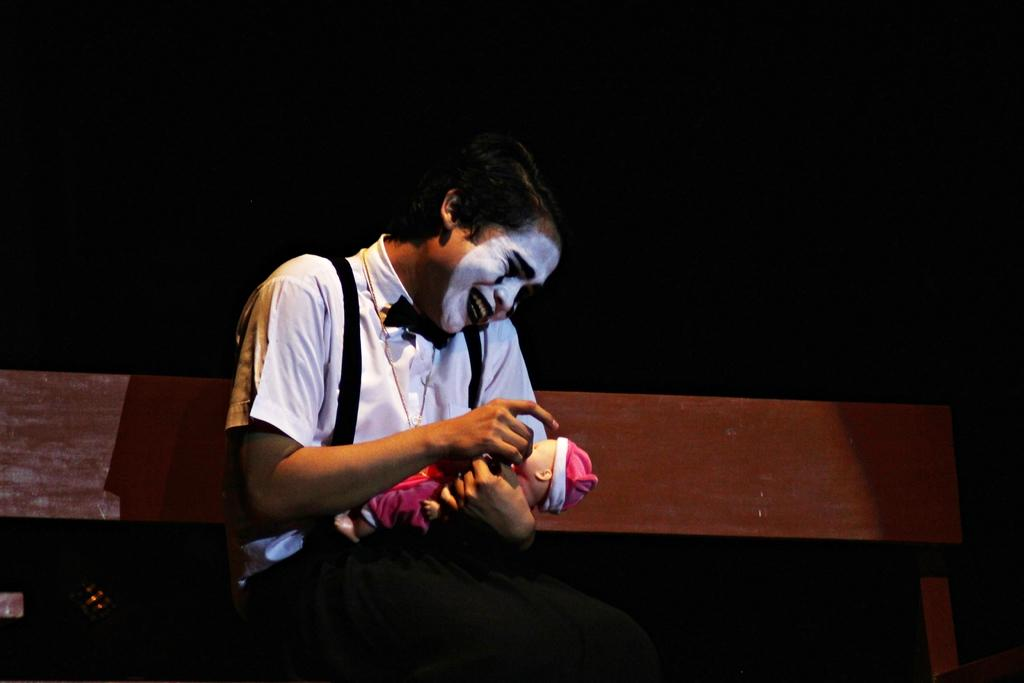What is the person in the image doing? The person is sitting on a bench in the image. What object is the person holding? The person is holding a small doll. Can you describe any other objects or features in the image? There is a painting of a person's face in the image. What type of bean is being used as a curtain in the image? There is no bean or curtain present in the image. Is there a beggar visible in the image? There is no beggar mentioned or visible in the image. 